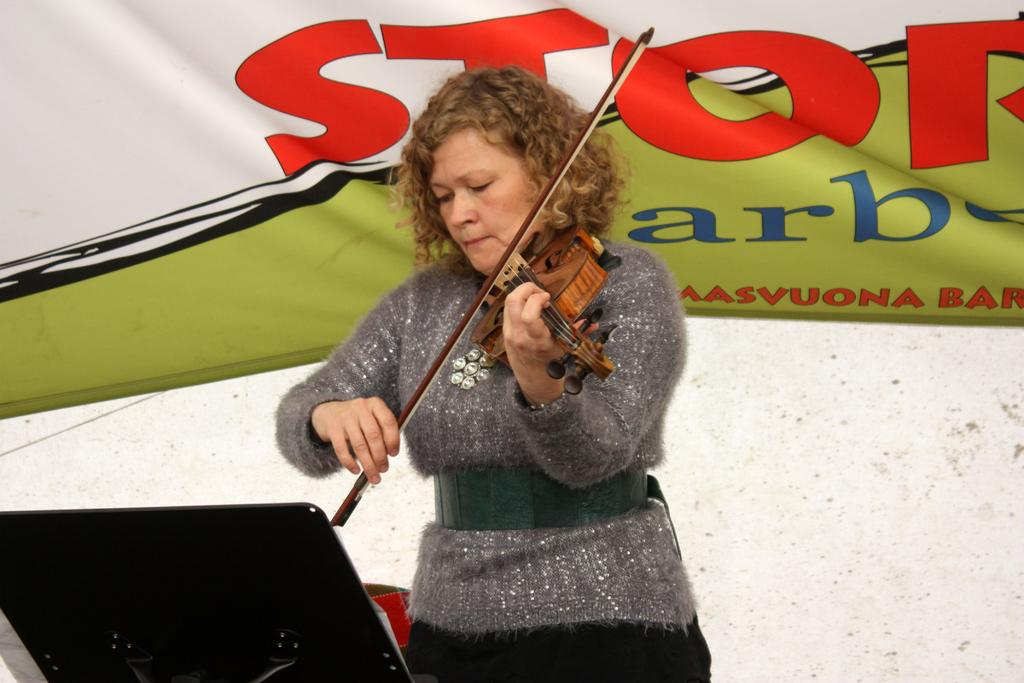What is the main subject of the image? The main subject of the image is a woman. What is the woman doing in the image? The woman is standing and holding a musical instrument. Is there any furniture or equipment in front of the woman? Yes, there is a stand in front of the woman. What can be seen in the background of the image? There is a banner in the background of the image. What type of thread is being used to create the banner in the image? There is no information about the type of thread used to create the banner in the image. Additionally, the image does not show any thread being used. 